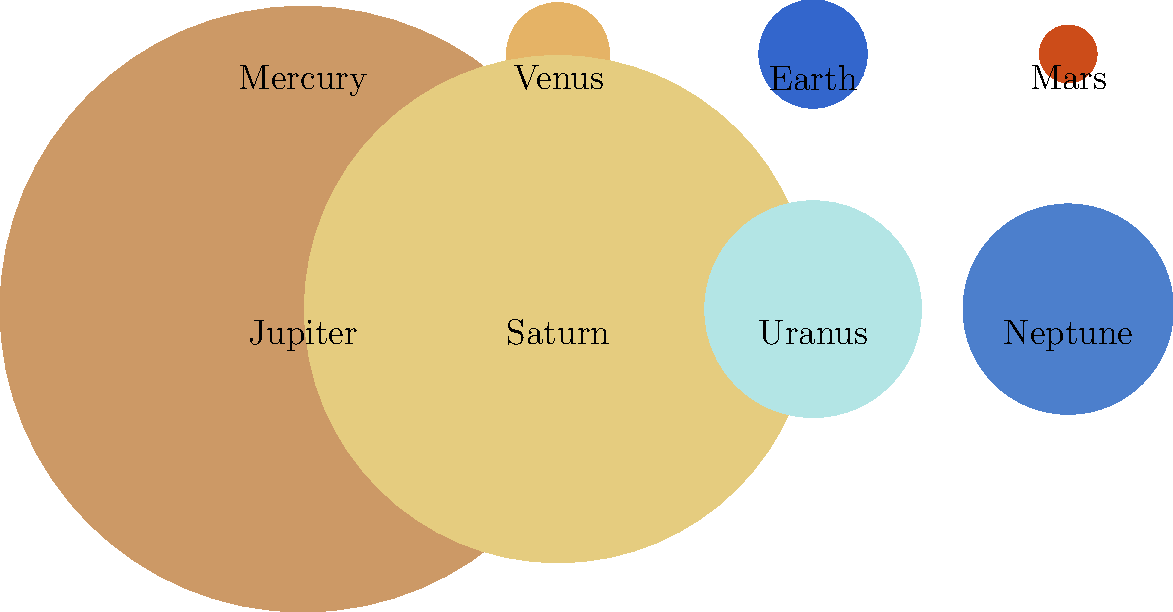In this scaled representation of our solar system's planets, which planet appears to have a diameter approximately half that of Jupiter's? To answer this question, we need to compare the sizes of the planets in the image:

1. Identify Jupiter: It's the largest circle in the image, colored beige.
2. Estimate half of Jupiter's diameter visually.
3. Compare this estimated half-diameter to the other planets:
   - Mercury, Venus, Earth, and Mars are much smaller.
   - Saturn is slightly smaller than Jupiter.
   - Uranus and Neptune are significantly smaller than Jupiter but larger than the inner planets.

4. Observe that Uranus and Neptune are very close in size.
5. Estimate that their diameters are approximately half of Jupiter's.

In reality, Uranus has a diameter of about 51,118 km, while Jupiter's is 142,984 km. This means Uranus is about 35.7% the diameter of Jupiter, which is reasonably close to half when represented in a scaled diagram.

Neptune is slightly smaller than Uranus, with a diameter of 49,528 km, or about 34.6% of Jupiter's diameter.

Given the scaled nature of the diagram and the visual comparison required, either Uranus or Neptune could be considered correct, but Uranus is slightly closer to half of Jupiter's size.
Answer: Uranus 